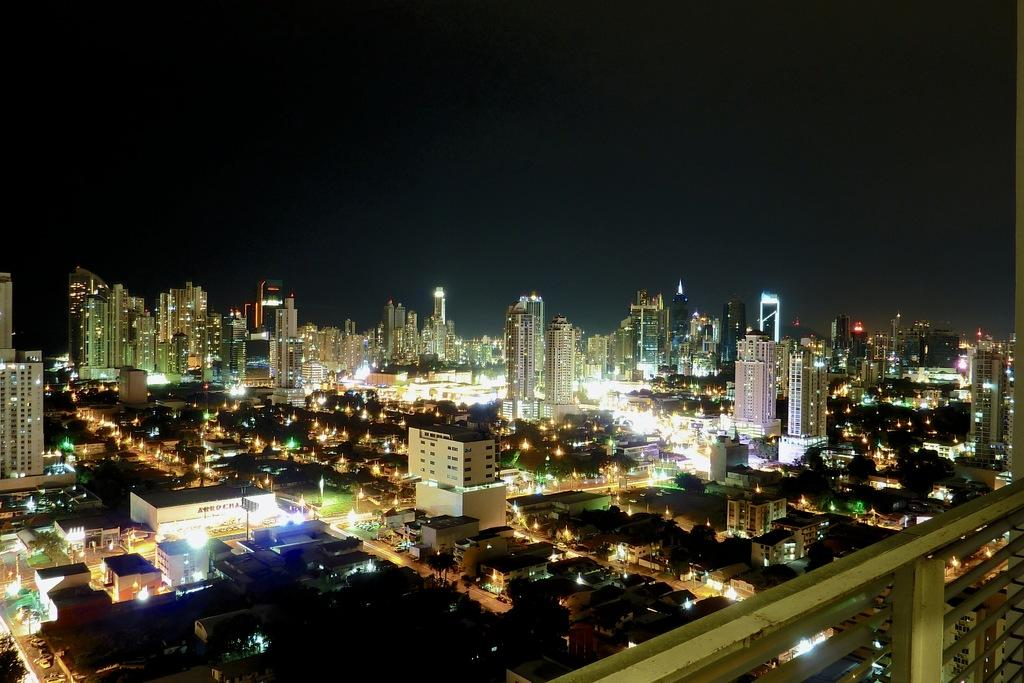What is the perspective of the image? The image shows a top view of a city. What can be seen in the city? There are lights visible in the city. What is the color of the sky in the image? The sky is dark in the image. What type of brain is visible in the image? There is no brain visible in the image; it shows a top view of a city. What material is the base of the city made of? The image does not provide information about the material of the city's base. 